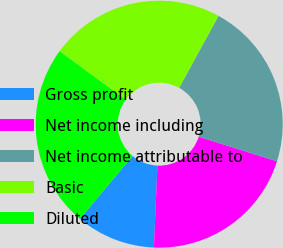Convert chart. <chart><loc_0><loc_0><loc_500><loc_500><pie_chart><fcel>Gross profit<fcel>Net income including<fcel>Net income attributable to<fcel>Basic<fcel>Diluted<nl><fcel>10.42%<fcel>20.83%<fcel>21.88%<fcel>22.92%<fcel>23.96%<nl></chart> 